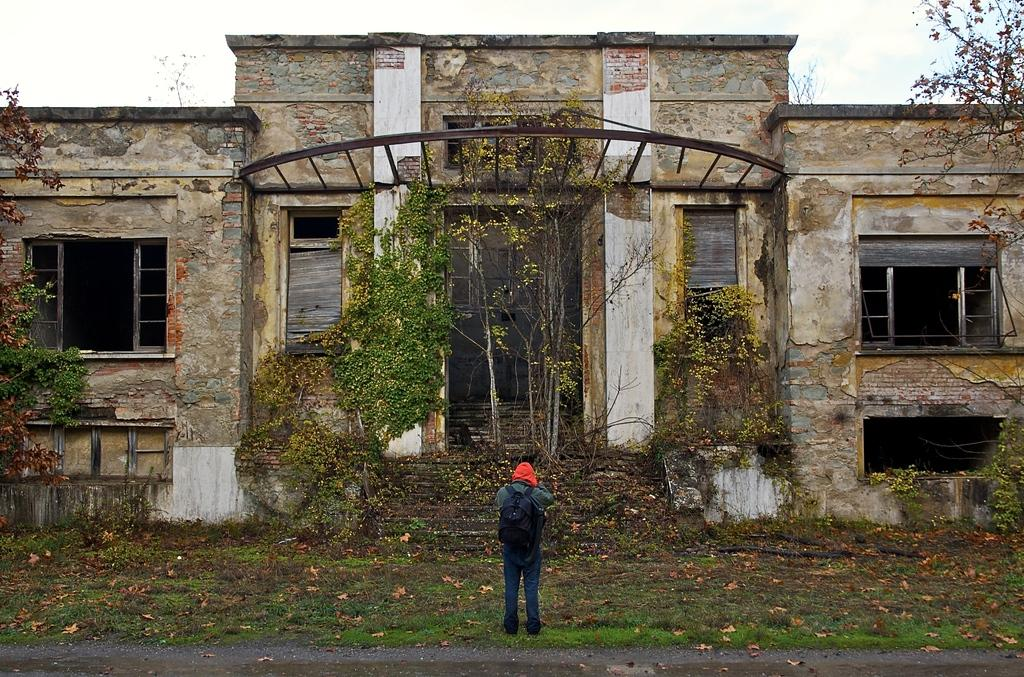What is the main subject of the image? There is a person in the image. What is the person carrying? The person is carrying a bag. Where is the person standing? The person is standing on the grass. What other elements can be seen in the image? The image contains a road, dried leaves, trees, a building with windows, and the sky is visible in the background. What type of baby is the person holding in the image? There is no baby present in the image; the person is only carrying a bag. How many family members can be seen in the image? There is only one person visible in the image, so it cannot be determined if there are any family members present. 